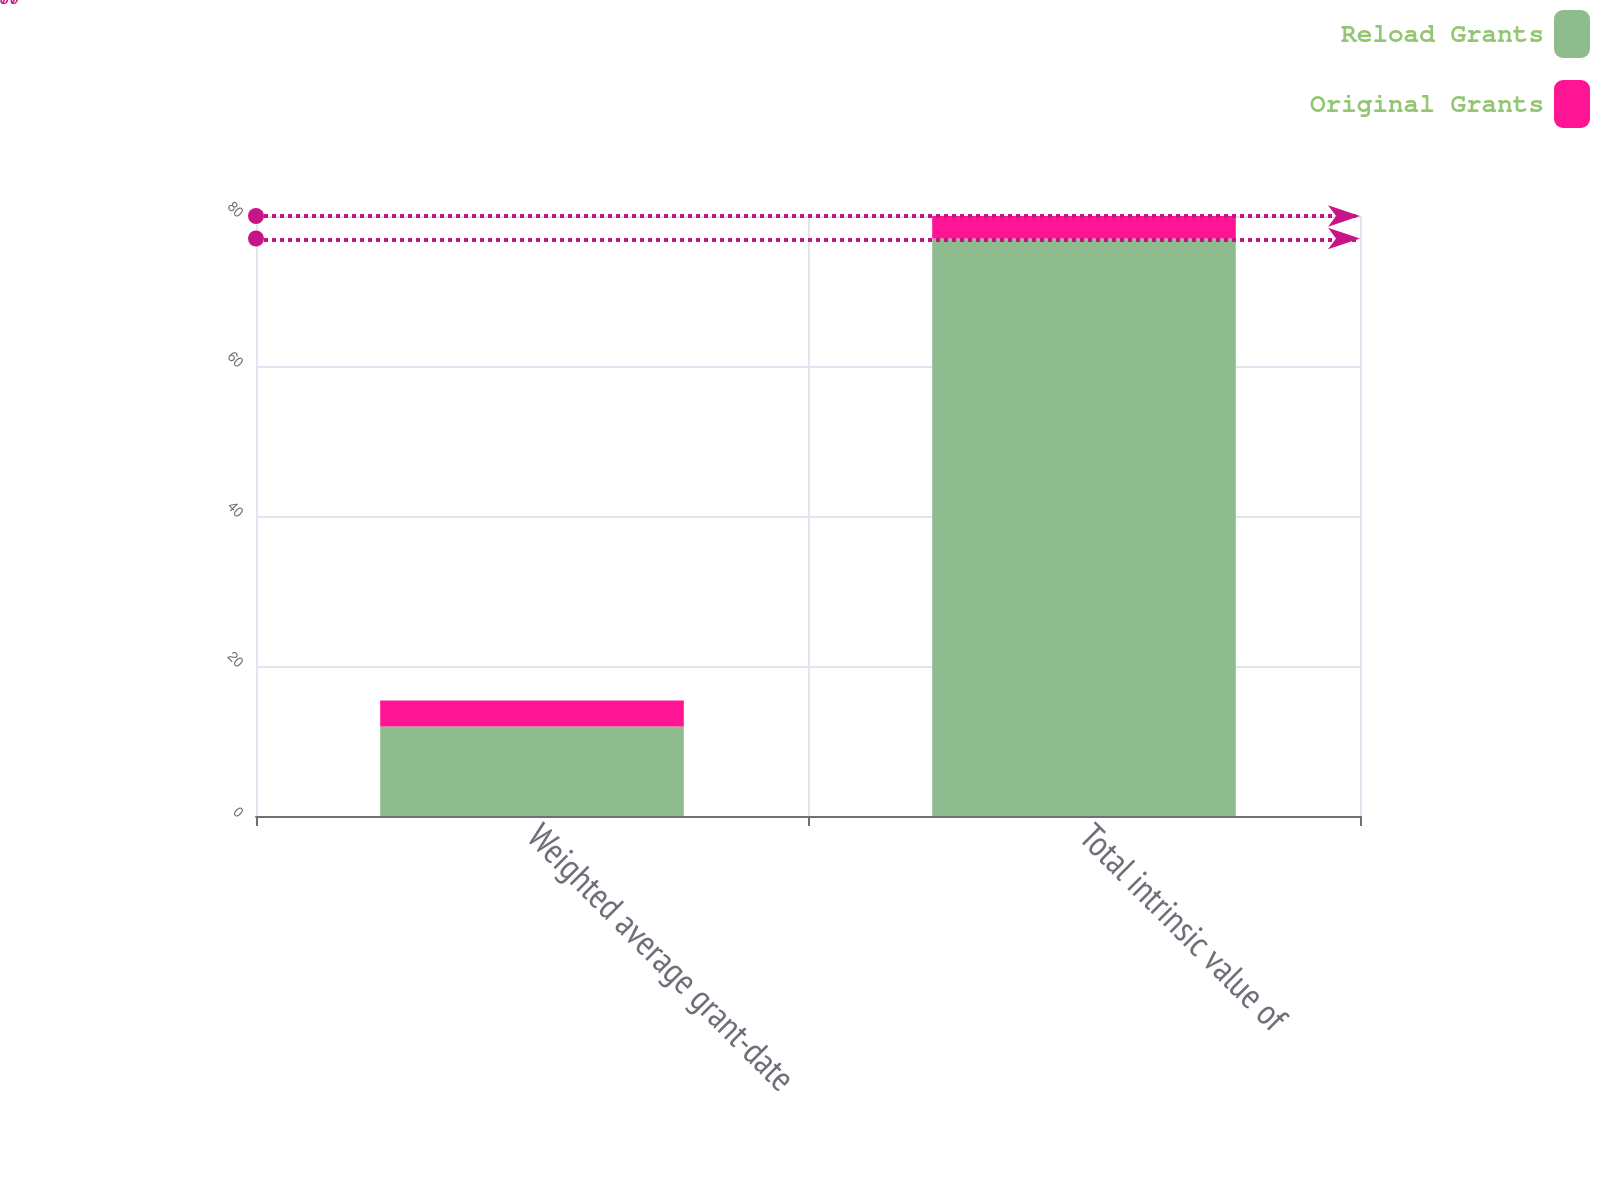Convert chart. <chart><loc_0><loc_0><loc_500><loc_500><stacked_bar_chart><ecel><fcel>Weighted average grant-date<fcel>Total intrinsic value of<nl><fcel>Reload Grants<fcel>11.94<fcel>77<nl><fcel>Original Grants<fcel>3.46<fcel>3<nl></chart> 